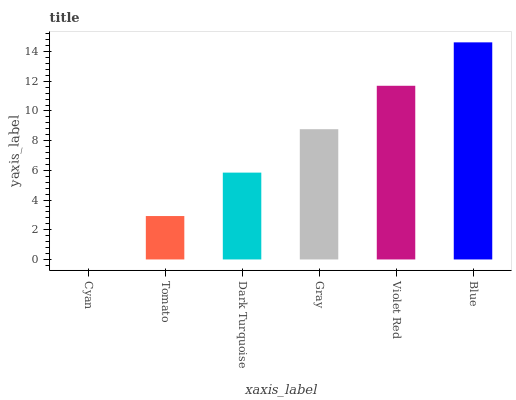Is Cyan the minimum?
Answer yes or no. Yes. Is Blue the maximum?
Answer yes or no. Yes. Is Tomato the minimum?
Answer yes or no. No. Is Tomato the maximum?
Answer yes or no. No. Is Tomato greater than Cyan?
Answer yes or no. Yes. Is Cyan less than Tomato?
Answer yes or no. Yes. Is Cyan greater than Tomato?
Answer yes or no. No. Is Tomato less than Cyan?
Answer yes or no. No. Is Gray the high median?
Answer yes or no. Yes. Is Dark Turquoise the low median?
Answer yes or no. Yes. Is Violet Red the high median?
Answer yes or no. No. Is Violet Red the low median?
Answer yes or no. No. 